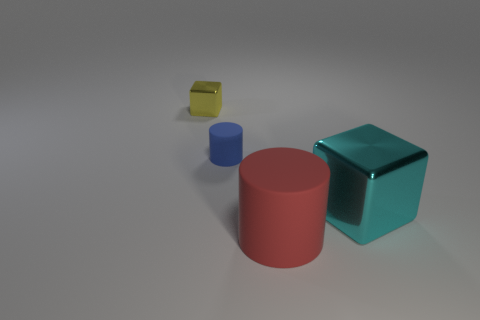Does the cylinder in front of the blue rubber object have the same size as the tiny yellow block?
Your answer should be compact. No. How big is the object that is both on the left side of the large cyan shiny cube and in front of the blue cylinder?
Keep it short and to the point. Large. What shape is the other object that is the same size as the blue rubber object?
Your answer should be very brief. Cube. What is the material of the large object to the left of the shiny block that is in front of the thing that is behind the small matte cylinder?
Give a very brief answer. Rubber. There is a thing right of the big matte cylinder; is its shape the same as the matte thing right of the blue rubber cylinder?
Ensure brevity in your answer.  No. How many other objects are the same material as the red cylinder?
Offer a terse response. 1. Are the block on the left side of the large rubber cylinder and the cube that is on the right side of the tiny yellow metal cube made of the same material?
Provide a succinct answer. Yes. The tiny yellow object that is made of the same material as the cyan block is what shape?
Your response must be concise. Cube. Is there any other thing that has the same color as the tiny shiny cube?
Offer a very short reply. No. What number of tiny red metallic balls are there?
Give a very brief answer. 0. 